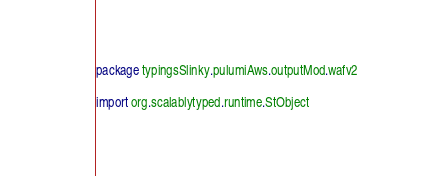<code> <loc_0><loc_0><loc_500><loc_500><_Scala_>package typingsSlinky.pulumiAws.outputMod.wafv2

import org.scalablytyped.runtime.StObject</code> 